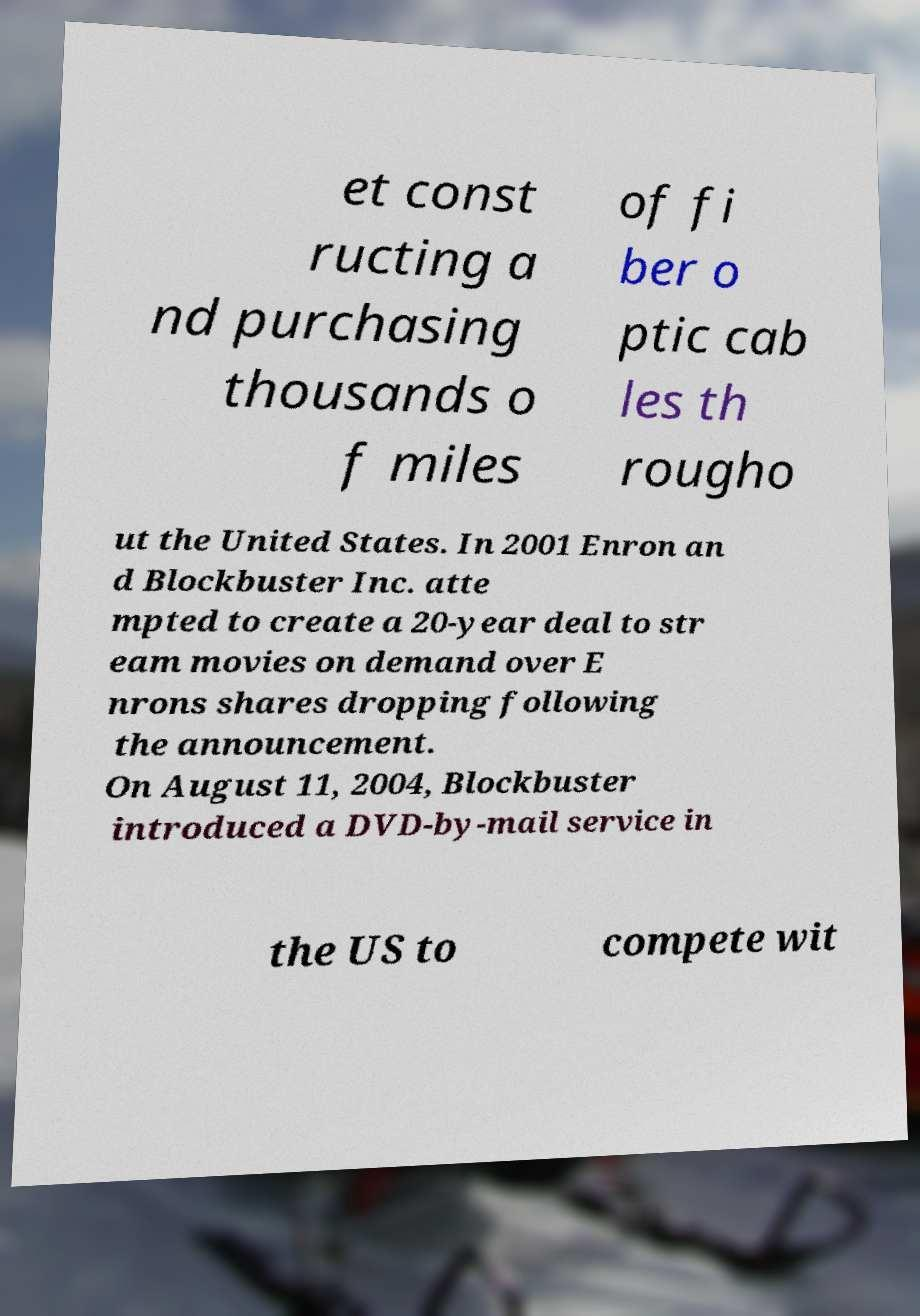Please read and relay the text visible in this image. What does it say? et const ructing a nd purchasing thousands o f miles of fi ber o ptic cab les th rougho ut the United States. In 2001 Enron an d Blockbuster Inc. atte mpted to create a 20-year deal to str eam movies on demand over E nrons shares dropping following the announcement. On August 11, 2004, Blockbuster introduced a DVD-by-mail service in the US to compete wit 